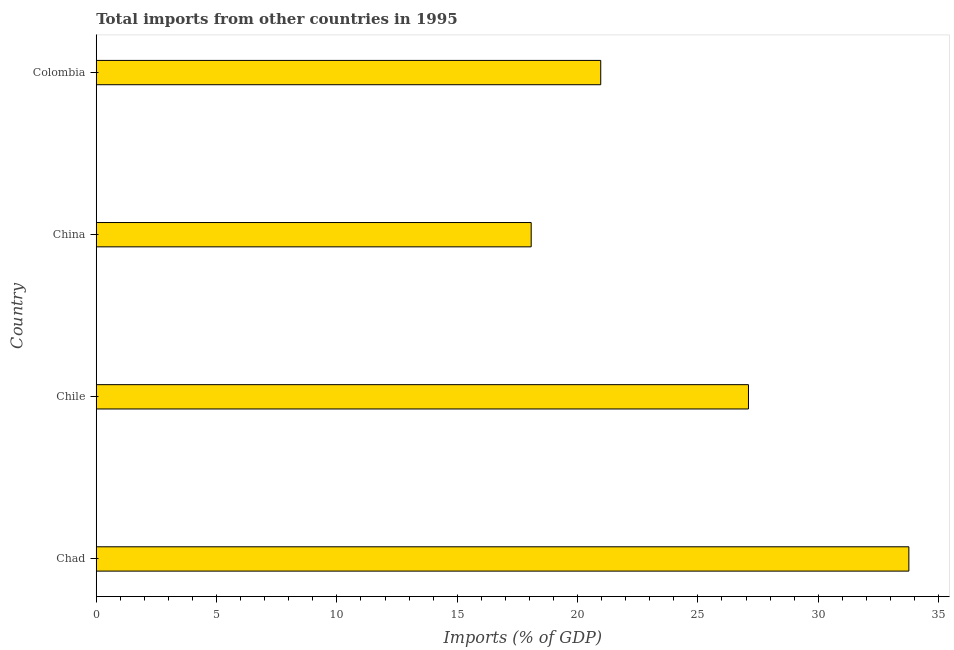Does the graph contain grids?
Your answer should be compact. No. What is the title of the graph?
Provide a short and direct response. Total imports from other countries in 1995. What is the label or title of the X-axis?
Offer a very short reply. Imports (% of GDP). What is the total imports in Chile?
Make the answer very short. 27.1. Across all countries, what is the maximum total imports?
Keep it short and to the point. 33.77. Across all countries, what is the minimum total imports?
Your answer should be very brief. 18.07. In which country was the total imports maximum?
Keep it short and to the point. Chad. In which country was the total imports minimum?
Make the answer very short. China. What is the sum of the total imports?
Offer a very short reply. 99.91. What is the difference between the total imports in Chad and Colombia?
Your answer should be compact. 12.8. What is the average total imports per country?
Your answer should be compact. 24.98. What is the median total imports?
Your response must be concise. 24.03. In how many countries, is the total imports greater than 3 %?
Provide a succinct answer. 4. What is the ratio of the total imports in Chad to that in Chile?
Your answer should be very brief. 1.25. Is the total imports in Chad less than that in Colombia?
Keep it short and to the point. No. Is the difference between the total imports in Chile and China greater than the difference between any two countries?
Your answer should be very brief. No. What is the difference between the highest and the second highest total imports?
Provide a succinct answer. 6.67. Is the sum of the total imports in China and Colombia greater than the maximum total imports across all countries?
Keep it short and to the point. Yes. What is the difference between the highest and the lowest total imports?
Keep it short and to the point. 15.69. In how many countries, is the total imports greater than the average total imports taken over all countries?
Your answer should be compact. 2. How many bars are there?
Provide a succinct answer. 4. Are all the bars in the graph horizontal?
Provide a succinct answer. Yes. What is the difference between two consecutive major ticks on the X-axis?
Ensure brevity in your answer.  5. Are the values on the major ticks of X-axis written in scientific E-notation?
Offer a very short reply. No. What is the Imports (% of GDP) of Chad?
Provide a succinct answer. 33.77. What is the Imports (% of GDP) in Chile?
Make the answer very short. 27.1. What is the Imports (% of GDP) of China?
Make the answer very short. 18.07. What is the Imports (% of GDP) in Colombia?
Your response must be concise. 20.96. What is the difference between the Imports (% of GDP) in Chad and Chile?
Offer a very short reply. 6.66. What is the difference between the Imports (% of GDP) in Chad and China?
Provide a succinct answer. 15.69. What is the difference between the Imports (% of GDP) in Chad and Colombia?
Offer a terse response. 12.8. What is the difference between the Imports (% of GDP) in Chile and China?
Keep it short and to the point. 9.03. What is the difference between the Imports (% of GDP) in Chile and Colombia?
Give a very brief answer. 6.14. What is the difference between the Imports (% of GDP) in China and Colombia?
Your answer should be very brief. -2.89. What is the ratio of the Imports (% of GDP) in Chad to that in Chile?
Your response must be concise. 1.25. What is the ratio of the Imports (% of GDP) in Chad to that in China?
Your answer should be very brief. 1.87. What is the ratio of the Imports (% of GDP) in Chad to that in Colombia?
Give a very brief answer. 1.61. What is the ratio of the Imports (% of GDP) in Chile to that in Colombia?
Provide a succinct answer. 1.29. What is the ratio of the Imports (% of GDP) in China to that in Colombia?
Your answer should be compact. 0.86. 